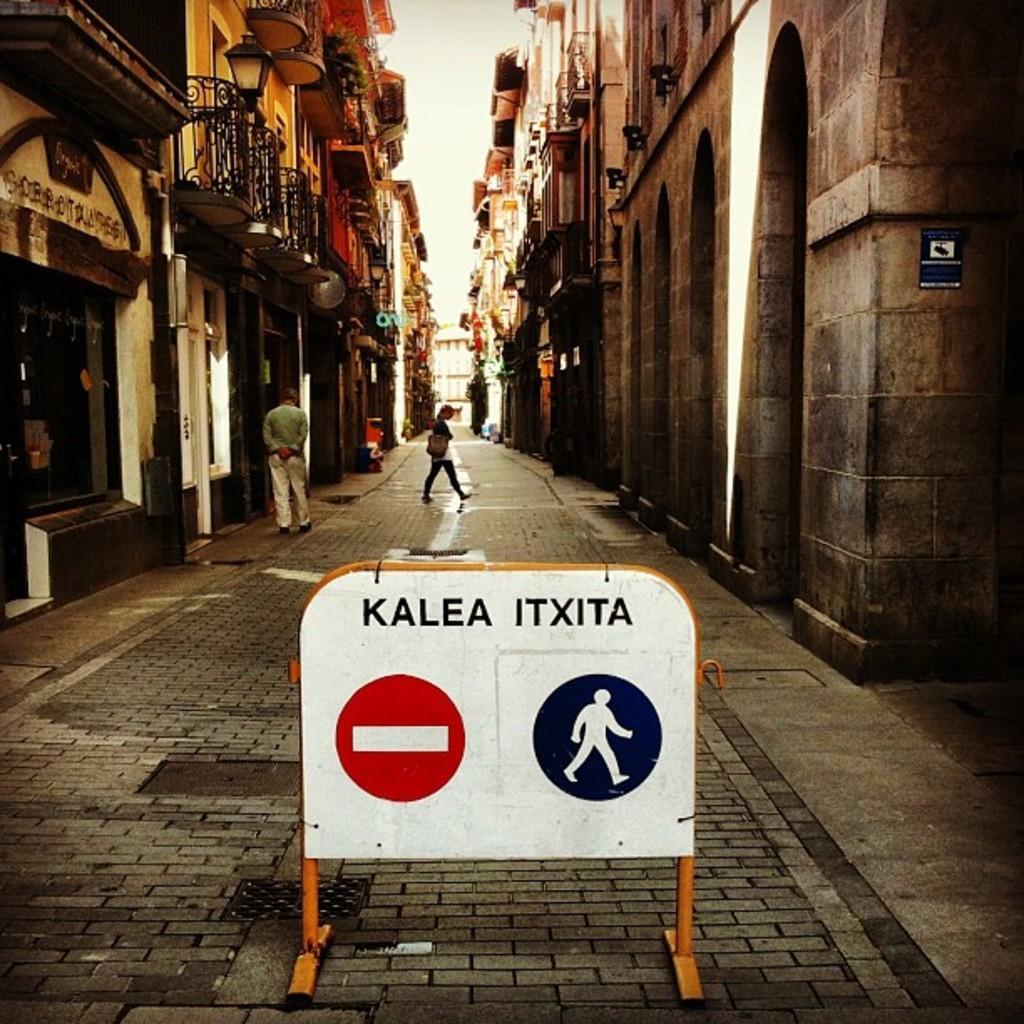How would you summarize this image in a sentence or two? In this picture we can see buildings on the right side and left side, there are two persons in the background, we can see a board in the front, we can see balconies of the buildings. 